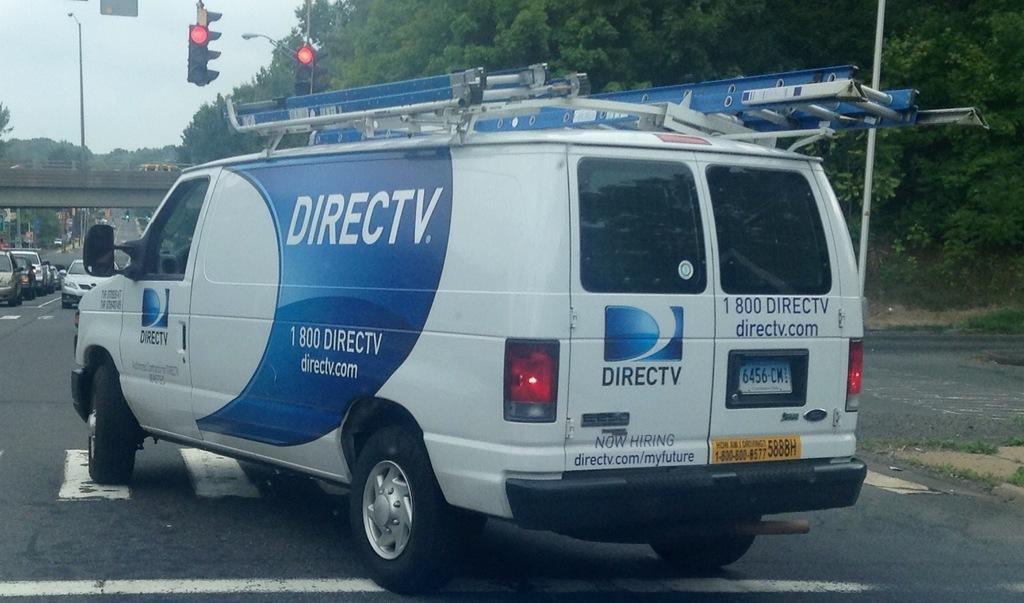How would you summarize this image in a sentence or two? In this image I can see a road in the front and on it I can see number of vehicles. In the centre of the image I can see something is written on the one vehicle. In the background I can see number of trees, few poles, a street light, few signal lights, a bridge and the sky. On the right side of the image I can see grass. 